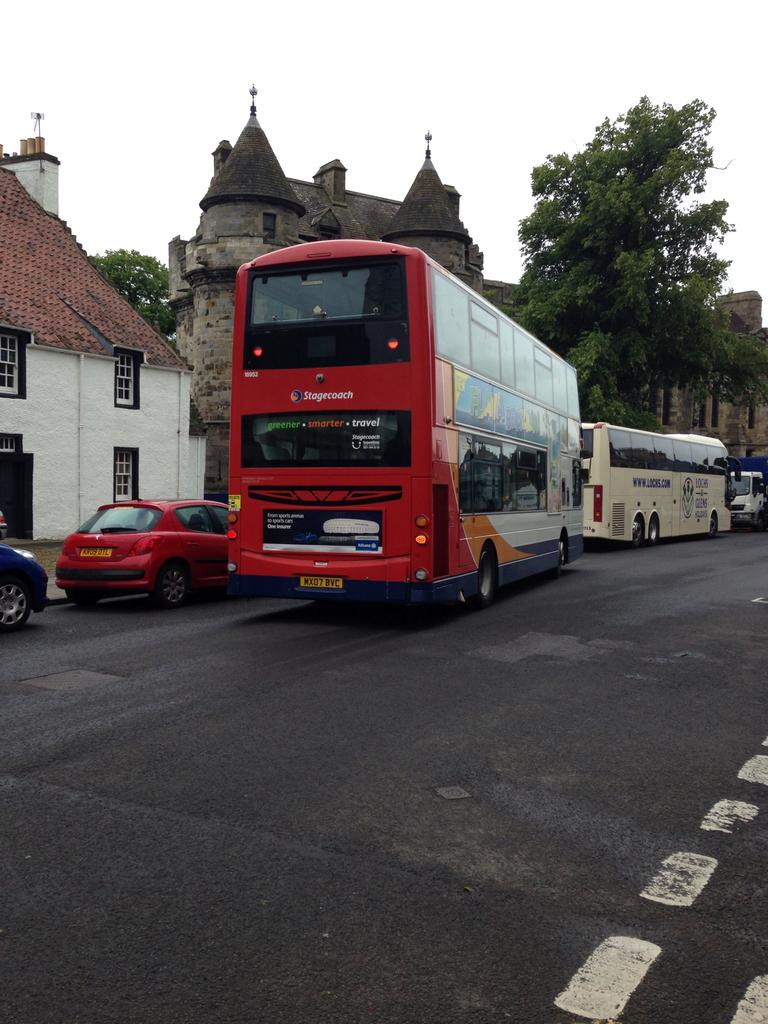<image>
Describe the image concisely. A double decker stagecoach bus with greener smarter travel on the back window. 